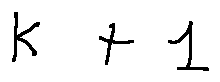<formula> <loc_0><loc_0><loc_500><loc_500>k + 1</formula> 